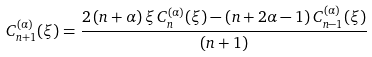<formula> <loc_0><loc_0><loc_500><loc_500>C _ { n + 1 } ^ { ( \alpha ) } ( \xi ) = \frac { 2 \, ( n + \alpha ) \, \xi \, C _ { n } ^ { ( \alpha ) } ( \xi ) - ( n + 2 \alpha - 1 ) \, C _ { n - 1 } ^ { ( \alpha ) } ( \xi ) } { ( n + 1 ) }</formula> 